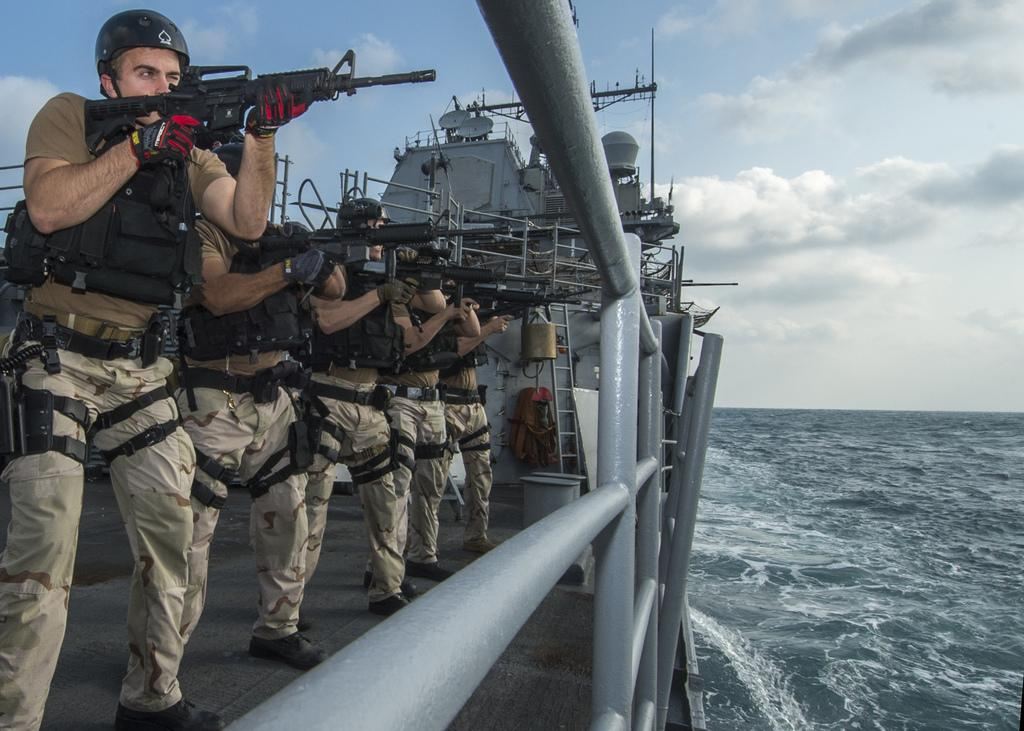What are the people in the image holding? The people in the image are holding guns. What can be seen in the water in the image? There is a ship visible in the water in the image. What is visible in the background of the image? The sky is visible in the background of the image. What can be observed in the sky? There are clouds in the sky. What is the name of the plantation in the image? There is no plantation present in the image. What type of current can be seen affecting the ship in the image? There is no indication of a current affecting the ship in the image. 